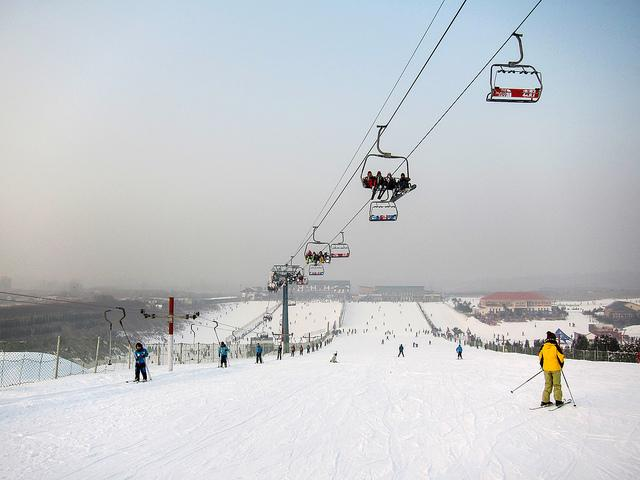What would happen if you cut the top wires? Please explain your reasoning. people injured. People would fall off the trams. 